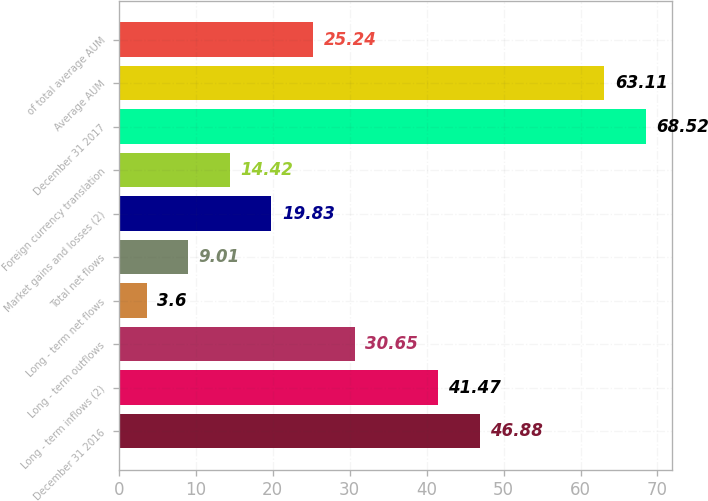Convert chart. <chart><loc_0><loc_0><loc_500><loc_500><bar_chart><fcel>December 31 2016<fcel>Long - term inflows (2)<fcel>Long - term outflows<fcel>Long - term net flows<fcel>Total net flows<fcel>Market gains and losses (2)<fcel>Foreign currency translation<fcel>December 31 2017<fcel>Average AUM<fcel>of total average AUM<nl><fcel>46.88<fcel>41.47<fcel>30.65<fcel>3.6<fcel>9.01<fcel>19.83<fcel>14.42<fcel>68.52<fcel>63.11<fcel>25.24<nl></chart> 